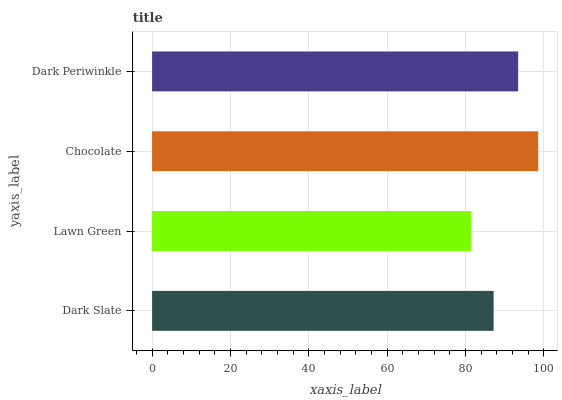Is Lawn Green the minimum?
Answer yes or no. Yes. Is Chocolate the maximum?
Answer yes or no. Yes. Is Chocolate the minimum?
Answer yes or no. No. Is Lawn Green the maximum?
Answer yes or no. No. Is Chocolate greater than Lawn Green?
Answer yes or no. Yes. Is Lawn Green less than Chocolate?
Answer yes or no. Yes. Is Lawn Green greater than Chocolate?
Answer yes or no. No. Is Chocolate less than Lawn Green?
Answer yes or no. No. Is Dark Periwinkle the high median?
Answer yes or no. Yes. Is Dark Slate the low median?
Answer yes or no. Yes. Is Lawn Green the high median?
Answer yes or no. No. Is Chocolate the low median?
Answer yes or no. No. 